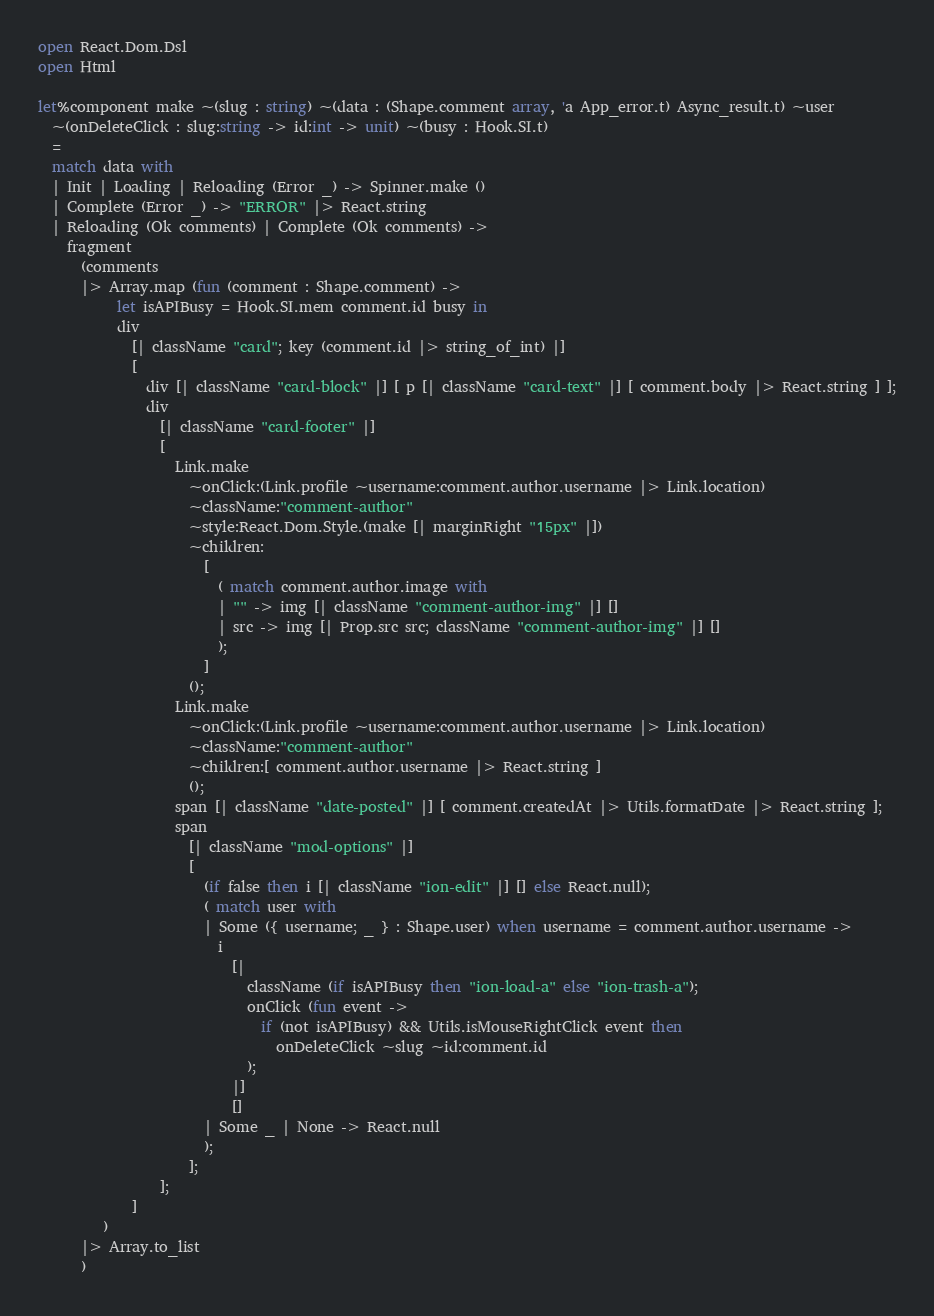<code> <loc_0><loc_0><loc_500><loc_500><_OCaml_>open React.Dom.Dsl
open Html

let%component make ~(slug : string) ~(data : (Shape.comment array, 'a App_error.t) Async_result.t) ~user
  ~(onDeleteClick : slug:string -> id:int -> unit) ~(busy : Hook.SI.t)
  =
  match data with
  | Init | Loading | Reloading (Error _) -> Spinner.make ()
  | Complete (Error _) -> "ERROR" |> React.string
  | Reloading (Ok comments) | Complete (Ok comments) ->
    fragment
      (comments
      |> Array.map (fun (comment : Shape.comment) ->
           let isAPIBusy = Hook.SI.mem comment.id busy in
           div
             [| className "card"; key (comment.id |> string_of_int) |]
             [
               div [| className "card-block" |] [ p [| className "card-text" |] [ comment.body |> React.string ] ];
               div
                 [| className "card-footer" |]
                 [
                   Link.make
                     ~onClick:(Link.profile ~username:comment.author.username |> Link.location)
                     ~className:"comment-author"
                     ~style:React.Dom.Style.(make [| marginRight "15px" |])
                     ~children:
                       [
                         ( match comment.author.image with
                         | "" -> img [| className "comment-author-img" |] []
                         | src -> img [| Prop.src src; className "comment-author-img" |] []
                         );
                       ]
                     ();
                   Link.make
                     ~onClick:(Link.profile ~username:comment.author.username |> Link.location)
                     ~className:"comment-author"
                     ~children:[ comment.author.username |> React.string ]
                     ();
                   span [| className "date-posted" |] [ comment.createdAt |> Utils.formatDate |> React.string ];
                   span
                     [| className "mod-options" |]
                     [
                       (if false then i [| className "ion-edit" |] [] else React.null);
                       ( match user with
                       | Some ({ username; _ } : Shape.user) when username = comment.author.username ->
                         i
                           [|
                             className (if isAPIBusy then "ion-load-a" else "ion-trash-a");
                             onClick (fun event ->
                               if (not isAPIBusy) && Utils.isMouseRightClick event then
                                 onDeleteClick ~slug ~id:comment.id
                             );
                           |]
                           []
                       | Some _ | None -> React.null
                       );
                     ];
                 ];
             ]
         )
      |> Array.to_list
      )
</code> 